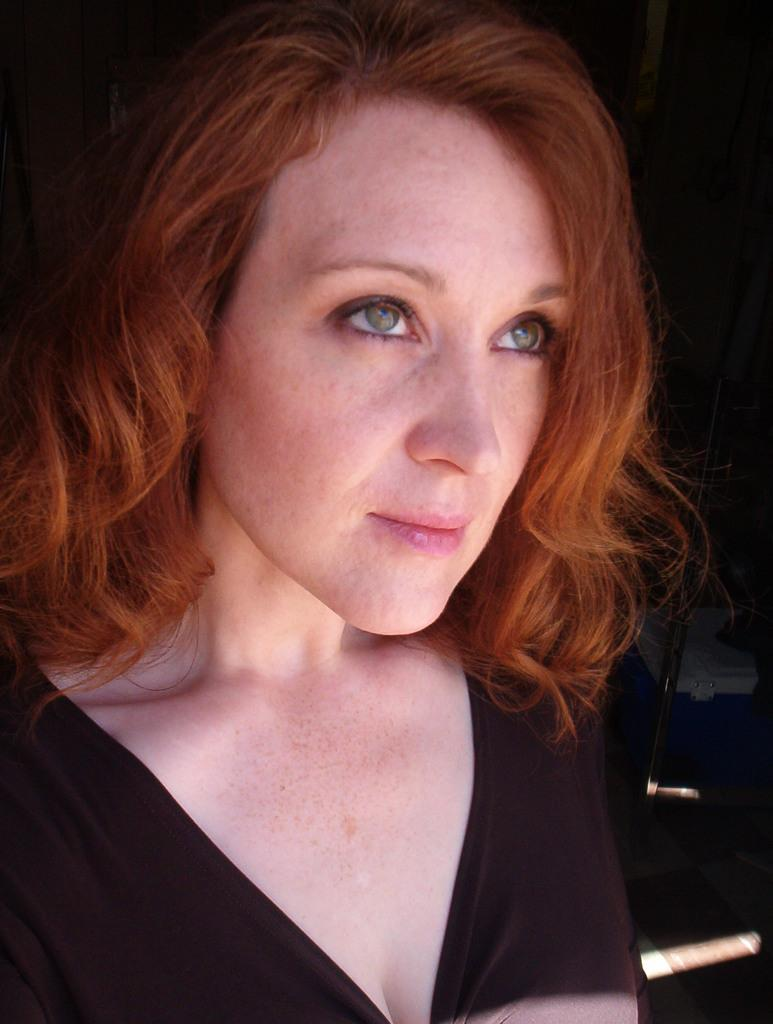Who or what is present in the image? There is a person in the image. What object can be seen on the right side of the image? There is a metal rod on the right side of the image. What is located on the floor in the image? There is a box on the floor in the image. What type of approval is the person seeking in the image? There is no indication in the image that the person is seeking any type of approval. 